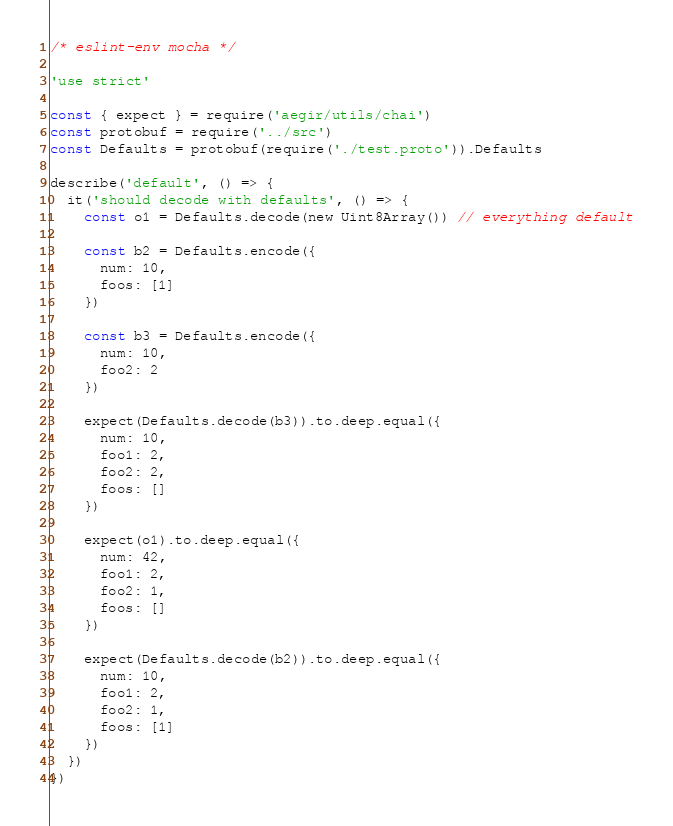<code> <loc_0><loc_0><loc_500><loc_500><_JavaScript_>/* eslint-env mocha */

'use strict'

const { expect } = require('aegir/utils/chai')
const protobuf = require('../src')
const Defaults = protobuf(require('./test.proto')).Defaults

describe('default', () => {
  it('should decode with defaults', () => {
    const o1 = Defaults.decode(new Uint8Array()) // everything default

    const b2 = Defaults.encode({
      num: 10,
      foos: [1]
    })

    const b3 = Defaults.encode({
      num: 10,
      foo2: 2
    })

    expect(Defaults.decode(b3)).to.deep.equal({
      num: 10,
      foo1: 2,
      foo2: 2,
      foos: []
    })

    expect(o1).to.deep.equal({
      num: 42,
      foo1: 2,
      foo2: 1,
      foos: []
    })

    expect(Defaults.decode(b2)).to.deep.equal({
      num: 10,
      foo1: 2,
      foo2: 1,
      foos: [1]
    })
  })
})
</code> 